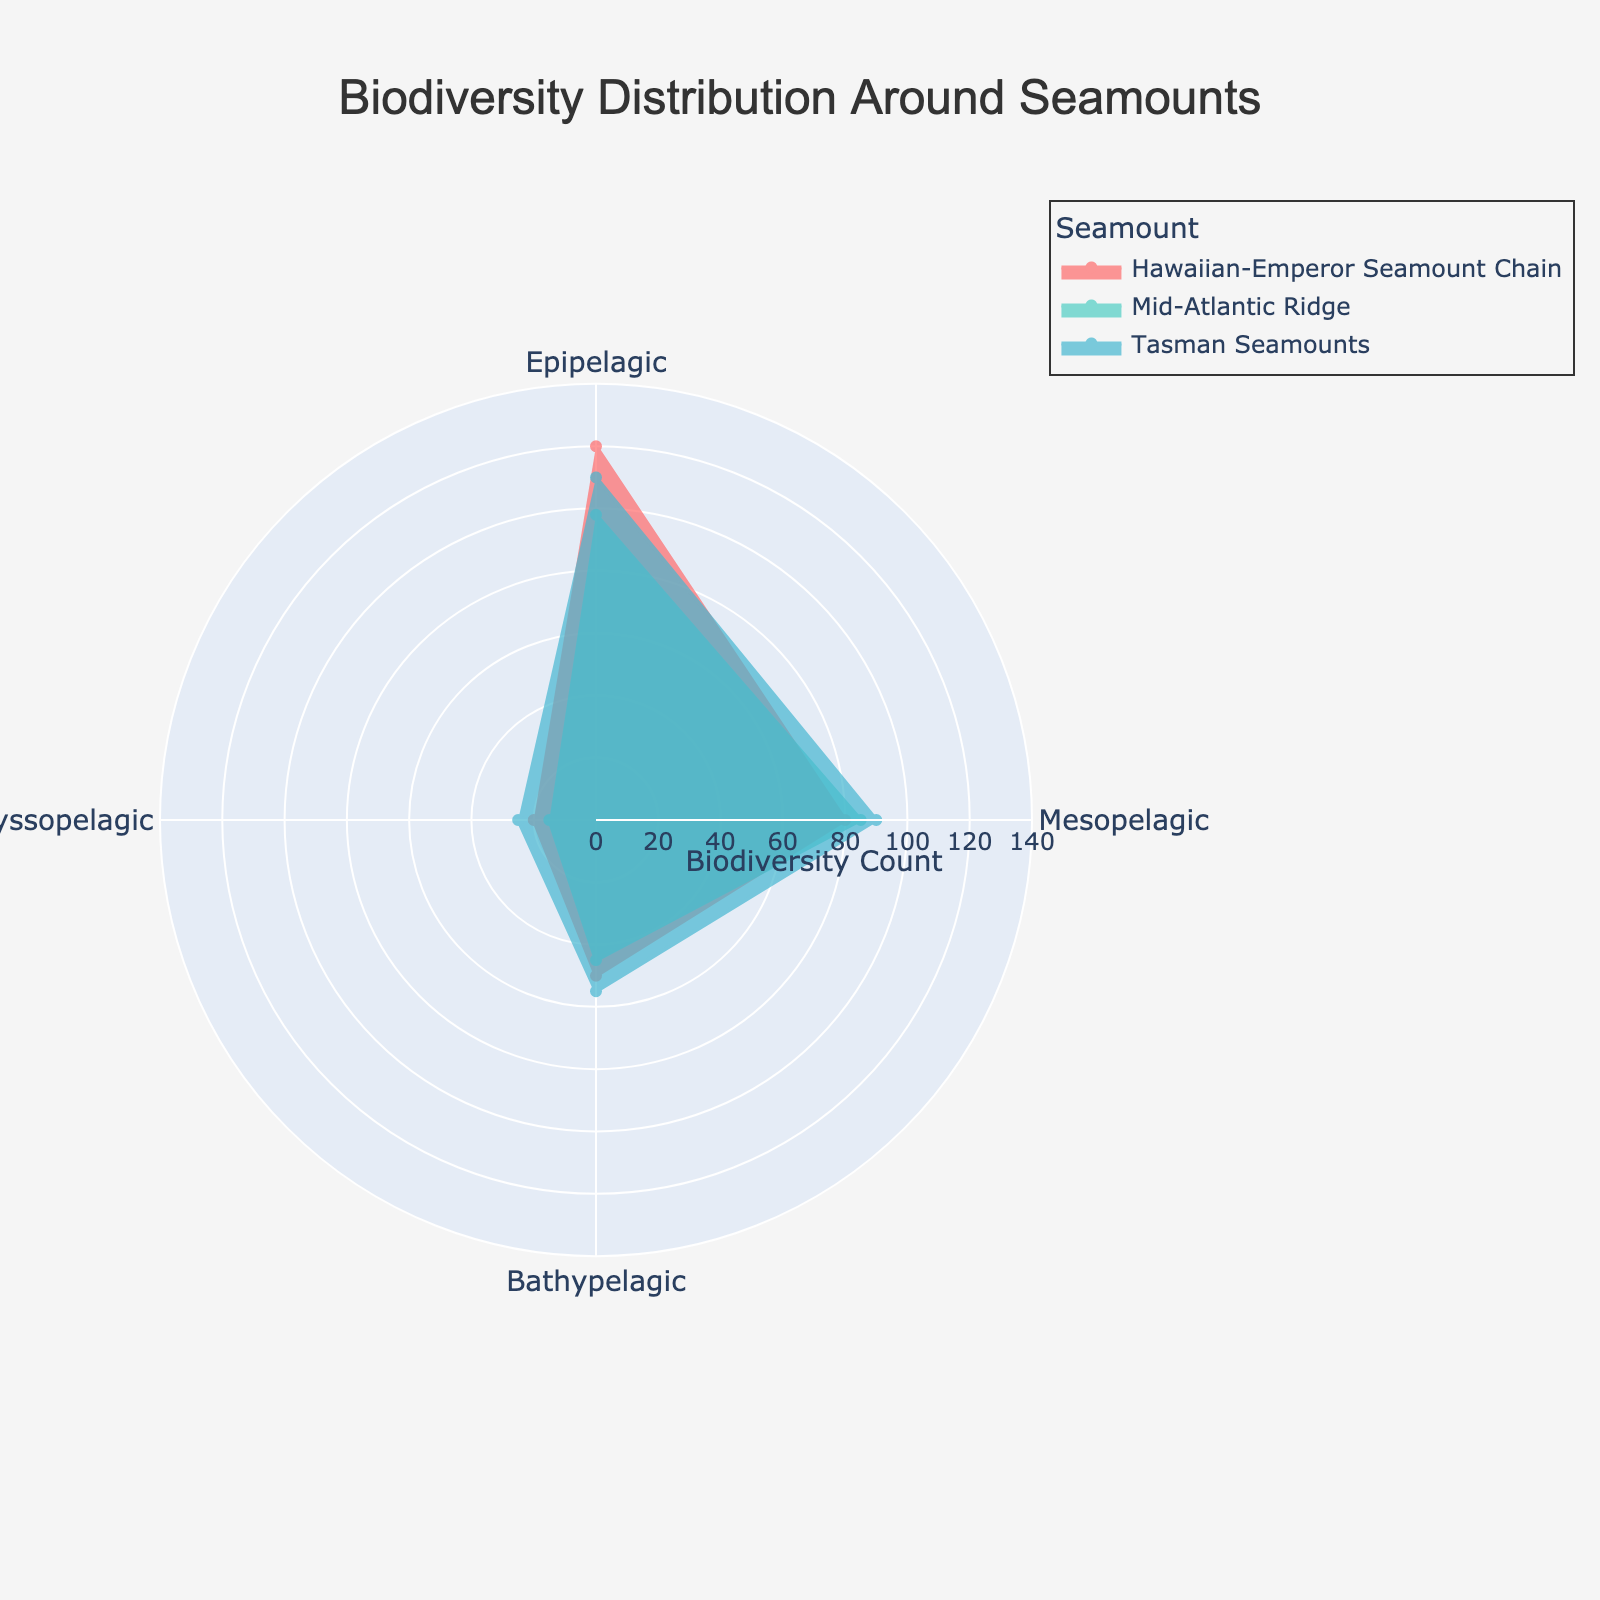What is the title of the chart? The title is visible at the top of the chart and is formatted prominently in larger font size compared to other text.
Answer: Biodiversity Distribution Around Seamounts How many oceanic zones are represented in the chart? You can count the distinct labels around the polar chart's angular axis to determine the number of oceanic zones.
Answer: 4 Which seamount has the highest biodiversity count in the Epipelagic zone? Locate the section of the chart corresponding to the Epipelagic zone and compare the lengths of the radial lines representing the biodiversity count for each seamount.
Answer: Hawaiian-Emperor Seamount Chain What is the difference in the biodiversity count between the Bathypelagic and Abyssopelagic zones for the Tasman Seamounts? Find the radial lengths for Tasman Seamounts in both the Bathypelagic and Abyssopelagic zones and subtract the Abyssopelagic count from the Bathypelagic count (55 - 25).
Answer: 30 Which oceanic zone has the lowest biodiversity count for the Mid-Atlantic Ridge? Compare the lengths of the radial lines representing the different zones for the Mid-Atlantic Ridge and identify the shortest one.
Answer: Abyssopelagic What's the total biodiversity count across all zones for the Hawaiian-Emperor Seamount Chain? Sum the radial values of the Hawaiian-Emperor Seamount Chain in all four zones (120 + 80 + 50 + 20).
Answer: 270 Which seamount shows the most consistent biodiversity distribution across all oceanic zones? Compare the radial values of each seamount across all zones, looking for the one with the smallest range (difference between maximum and minimum values).
Answer: Tasman Seamounts What is the average biodiversity count for the Mesopelagic zone across all seamounts? Add the biodiversity counts for the Mesopelagic zone for each seamount (80 + 85 + 90) and divide by the number of seamounts (3).
Answer: 85 In which oceanic zone is the biodiversity count for the Mid-Atlantic Ridge closest to that of the Hawaiian-Emperor Seamount Chain? Compare the radial values for Mid-Atlantic Ridge and Hawaiian-Emperor Seamount Chain across all zones and find the pair with the smallest difference (98 vs 120 is the closest).
Answer: Epipelagic Which seamount dominates the chart in terms of biodiversity count in most zones? Determine which seamount has the highest value in the largest number of zones by comparing radial lengths directly.
Answer: Hawaiian-Emperor Seamount Chain 